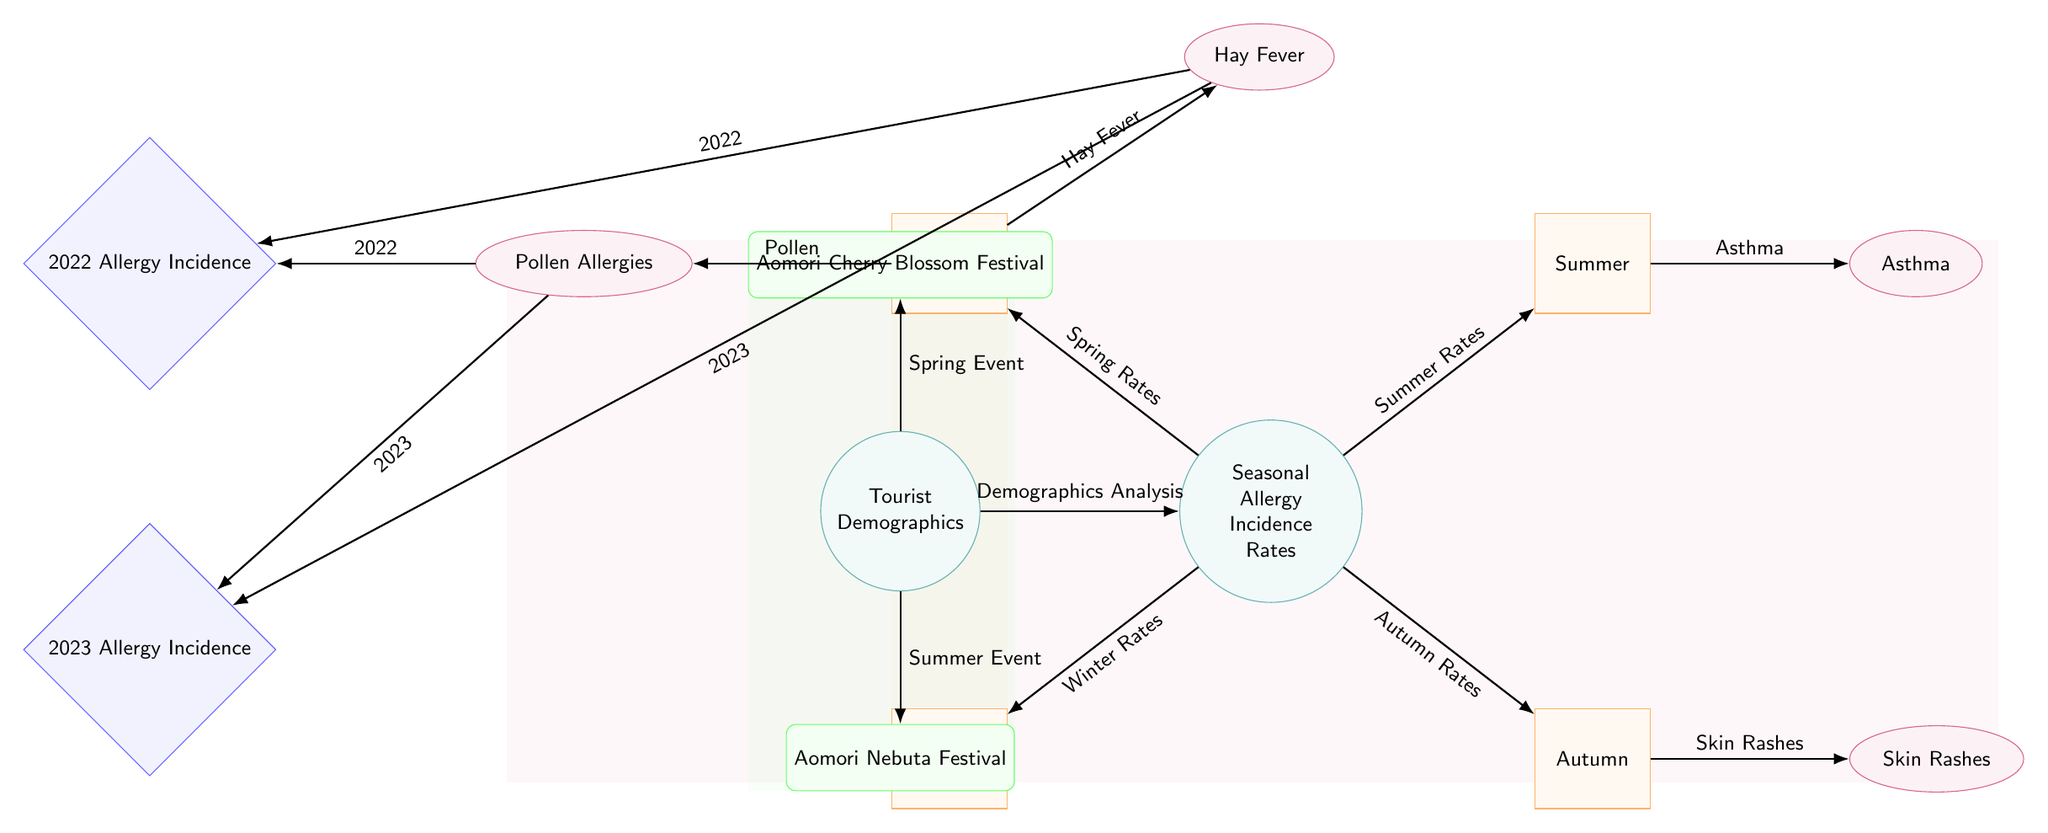What is the center node of the diagram? The center node is labeled "Seasonal Allergy Incidence Rates." This is the main topic of the diagram as indicated by its central position and the node's label.
Answer: Seasonal Allergy Incidence Rates How many seasons are represented in the diagram? The diagram includes four seasons: Spring, Summer, Autumn, and Winter. These are distinct nodes radiating from the central node.
Answer: 4 Which symptom is connected to Summer? The symptom connected to Summer is "Asthma". This is clearly shown by the edge leading from the Summer node to the Asthma node.
Answer: Asthma What are the two years represented for allergy incidence? The two years represented are 2022 and 2023, which are specifically linked to pollen allergies and hay fever symptoms.
Answer: 2022, 2023 Is there an event related to Spring? Yes, the event related to Spring is the "Aomori Cherry Blossom Festival," which connects to the demographics node.
Answer: Aomori Cherry Blossom Festival What symptom shows a direct connection to Spring? The symptoms that show direct connections to Spring are "Pollen Allergies" and "Hay Fever." Both symptoms are linked directly to the Spring season node.
Answer: Pollen Allergies, Hay Fever Which season has a direct link to Skin Rashes? Skin Rashes are directly linked to the Autumn season. This is indicated by the edge from Autumn leading to the Skin Rashes node.
Answer: Autumn How does demographics analysis relate to seasonal allergy incidence rates? The demographics analysis is connected to the central node "Seasonal Allergy Incidence Rates" indicating that the analysis impacts or informs the understanding of incidence rates.
Answer: Demographics Analysis Which season does not have a symptom displayed in the diagram? Winter does not have any specific symptoms displayed directly connected to it in the diagram.
Answer: Winter 